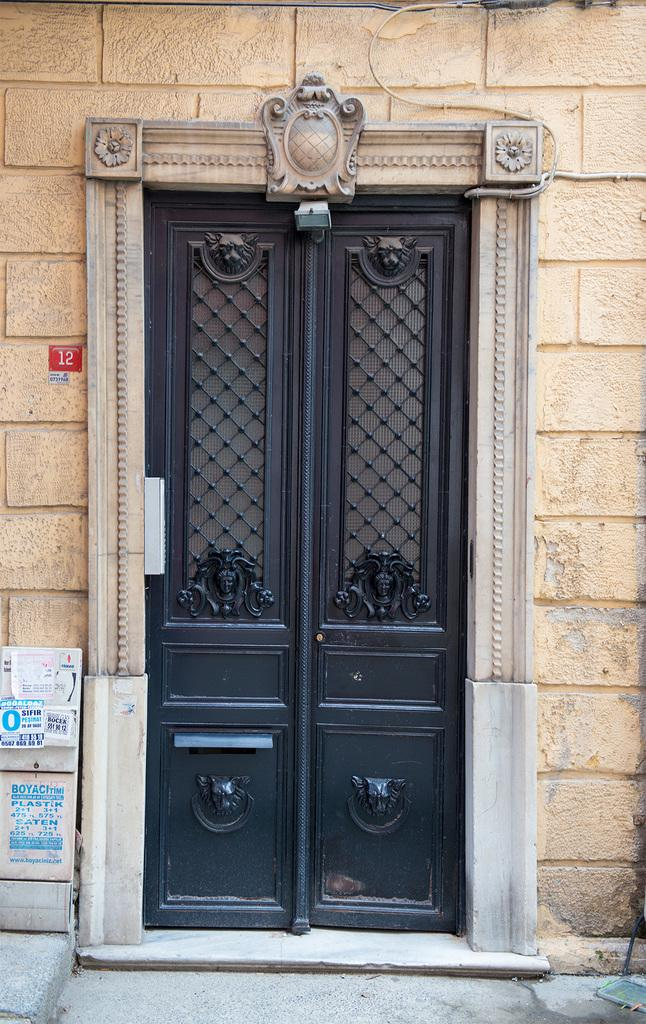What is one of the main features of the image? There is a door in the image. What color is the door? The door is black in color. What else can be seen in the image besides the door? There is a wall in the image. What color is the wall? The wall is cream in color. What is located to the left of the door? There are objects to the left of the door. What decorative elements are present on the objects? There are stickers on the objects. What type of shoe is visible on the head of the person in the image? There is no person or shoe present in the image; it only features a door, a wall, and objects with stickers. 